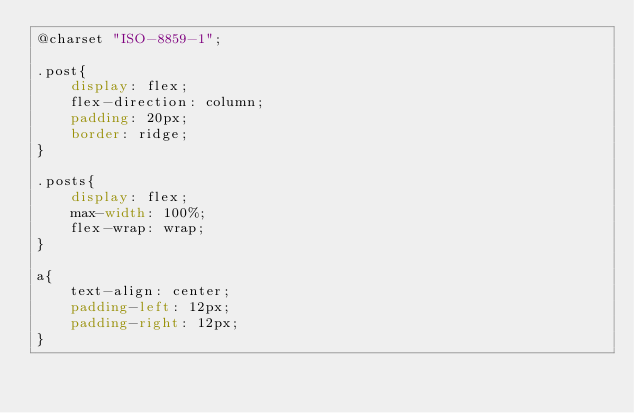<code> <loc_0><loc_0><loc_500><loc_500><_CSS_>@charset "ISO-8859-1";

.post{
	display: flex;
    flex-direction: column;
    padding: 20px;
    border: ridge;
}

.posts{
	display: flex;
	max-width: 100%;
    flex-wrap: wrap;
}

a{
	text-align: center;
    padding-left: 12px;
    padding-right: 12px;
}</code> 